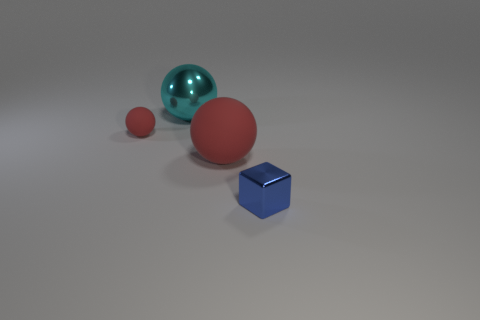Add 4 tiny matte balls. How many objects exist? 8 Subtract all spheres. How many objects are left? 1 Add 2 blue cubes. How many blue cubes exist? 3 Subtract 1 blue cubes. How many objects are left? 3 Subtract all small purple rubber cylinders. Subtract all blocks. How many objects are left? 3 Add 4 tiny blue things. How many tiny blue things are left? 5 